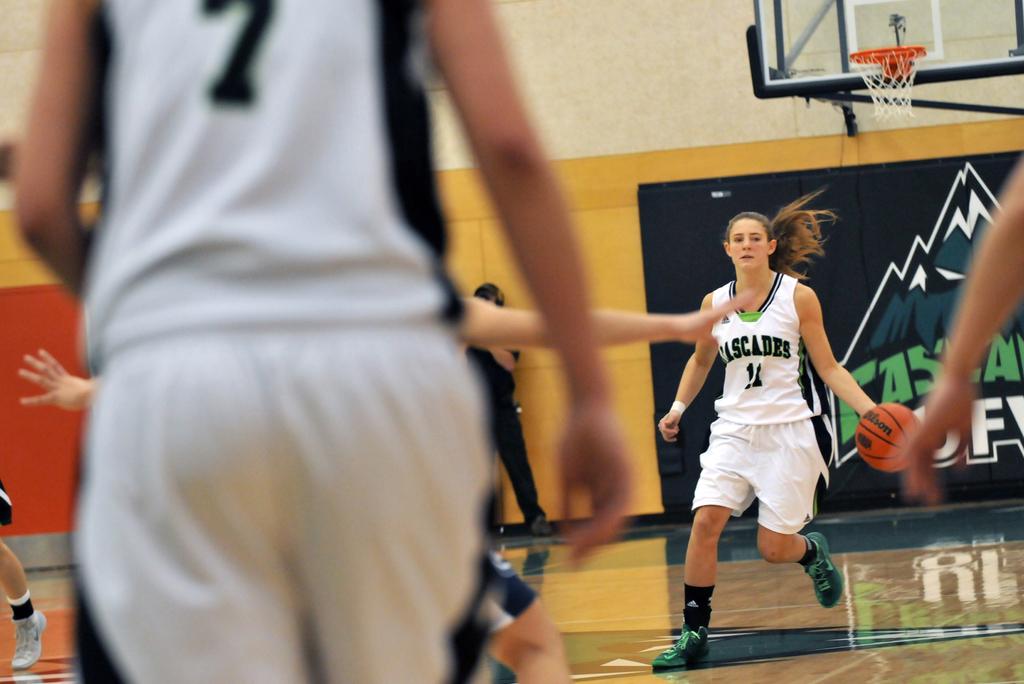What number is on the jersey?
Ensure brevity in your answer.  7. What team is this?
Your answer should be very brief. Cascades. 